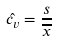<formula> <loc_0><loc_0><loc_500><loc_500>\hat { c _ { v } } = \frac { s } { \overline { x } }</formula> 